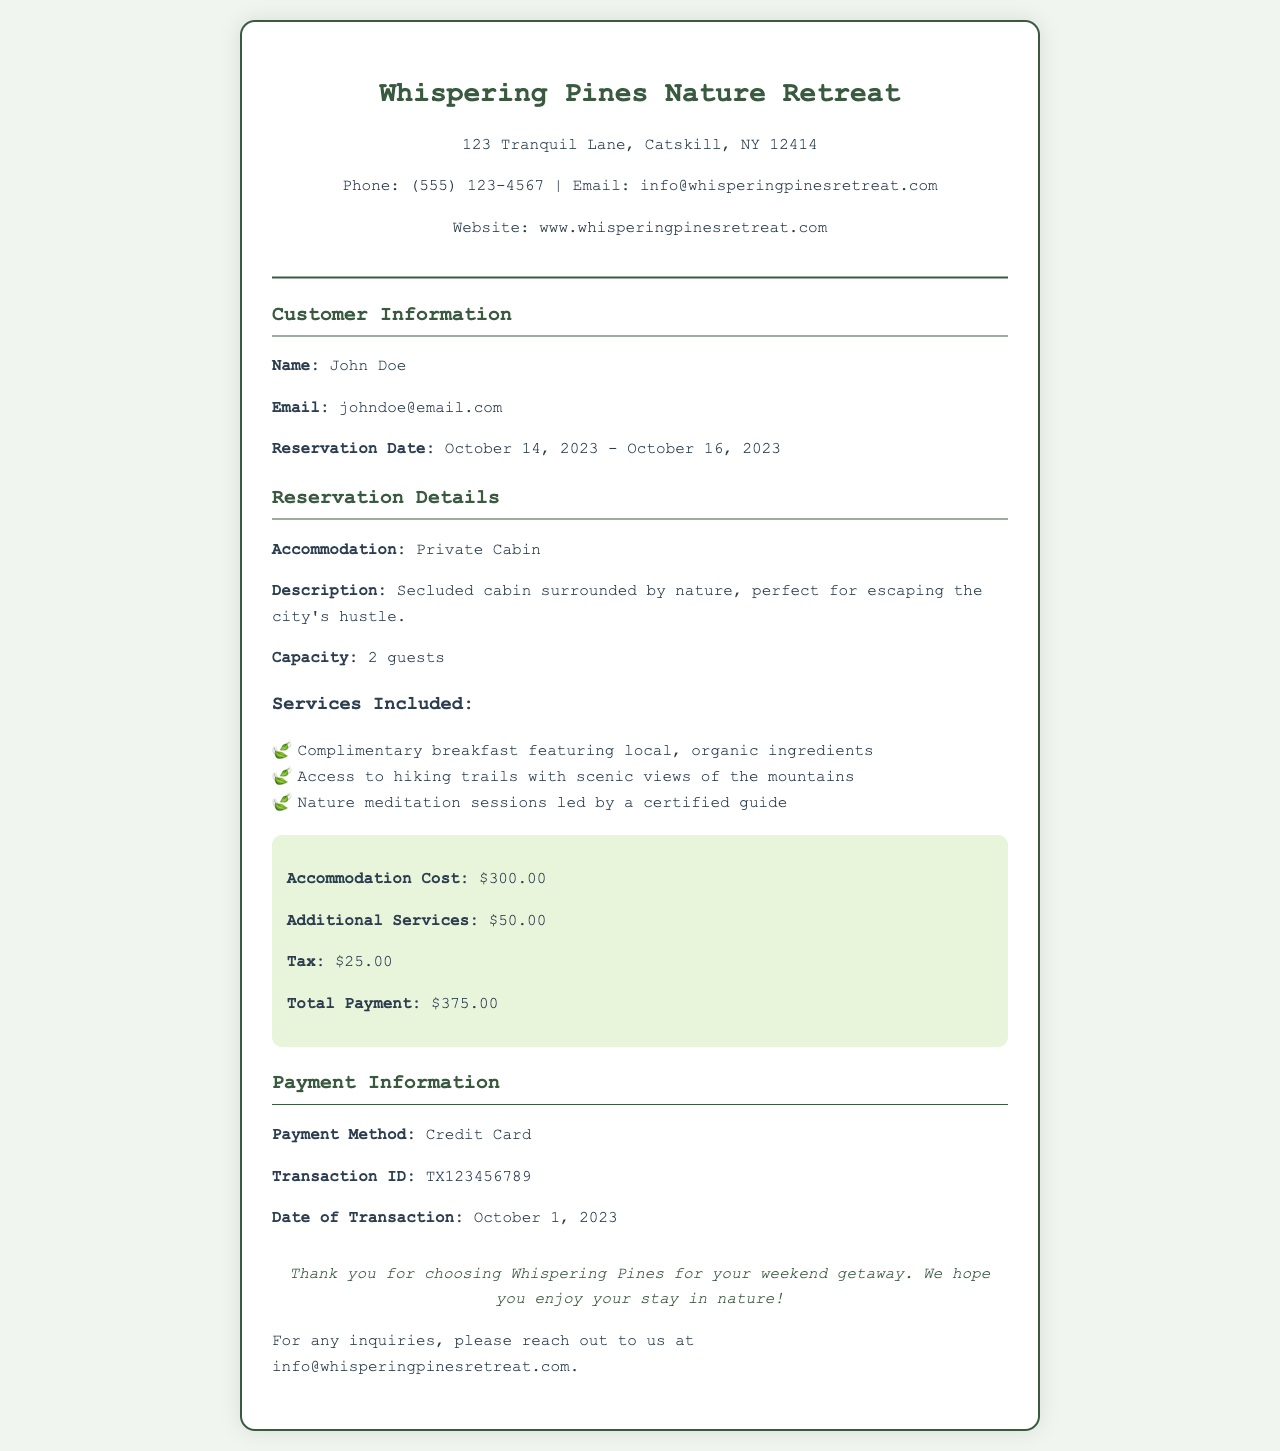What is the name of the retreat? The name of the retreat is stated prominently at the top of the document.
Answer: Whispering Pines Nature Retreat What is the address of the retreat? The address is provided under the retreat name in the document header.
Answer: 123 Tranquil Lane, Catskill, NY 12414 What is the total payment? The total payment is calculated from the accommodation cost, additional services, and tax provided in the document.
Answer: $375.00 What is the reservation date? The reservation date is listed in the customer information section of the document.
Answer: October 14, 2023 - October 16, 2023 How many guests can be accommodated? The capacity is mentioned in the reservation details section.
Answer: 2 guests What type of cabin is reserved? The type of accommodation is stated clearly in the reservation details.
Answer: Private Cabin What additional service costs are incurred? The document lists the additional services with their cost details in the price breakdown.
Answer: $50.00 What type of payment was used? The payment method is specified clearly in the payment information section.
Answer: Credit Card What meditation sessions are provided? The document describes the nature meditation sessions in the services included section.
Answer: Nature meditation sessions led by a certified guide 